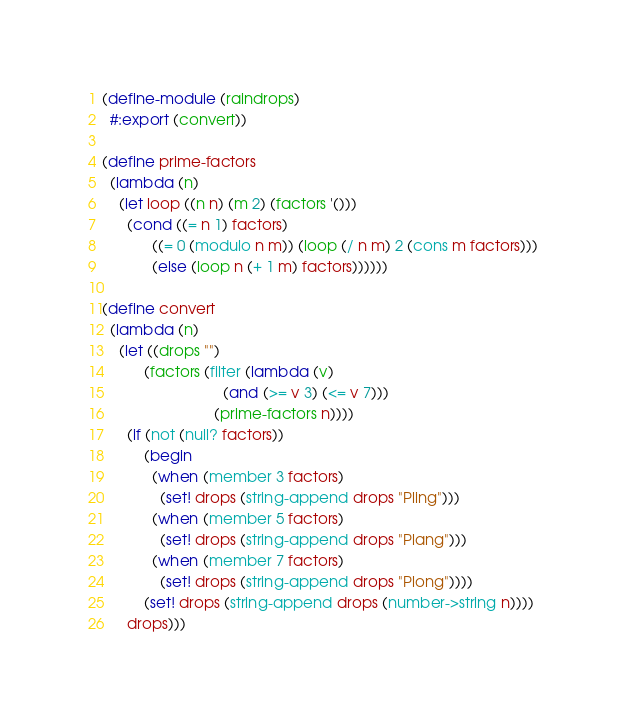Convert code to text. <code><loc_0><loc_0><loc_500><loc_500><_Scheme_>(define-module (raindrops)
  #:export (convert))

(define prime-factors
  (lambda (n)
    (let loop ((n n) (m 2) (factors '()))
      (cond ((= n 1) factors)
            ((= 0 (modulo n m)) (loop (/ n m) 2 (cons m factors)))
            (else (loop n (+ 1 m) factors))))))

(define convert
  (lambda (n)
    (let ((drops "")
          (factors (filter (lambda (v)
                             (and (>= v 3) (<= v 7)))
                           (prime-factors n))))
      (if (not (null? factors))
          (begin
            (when (member 3 factors)
              (set! drops (string-append drops "Pling")))
            (when (member 5 factors)
              (set! drops (string-append drops "Plang")))
            (when (member 7 factors)
              (set! drops (string-append drops "Plong"))))
          (set! drops (string-append drops (number->string n))))
      drops)))
</code> 